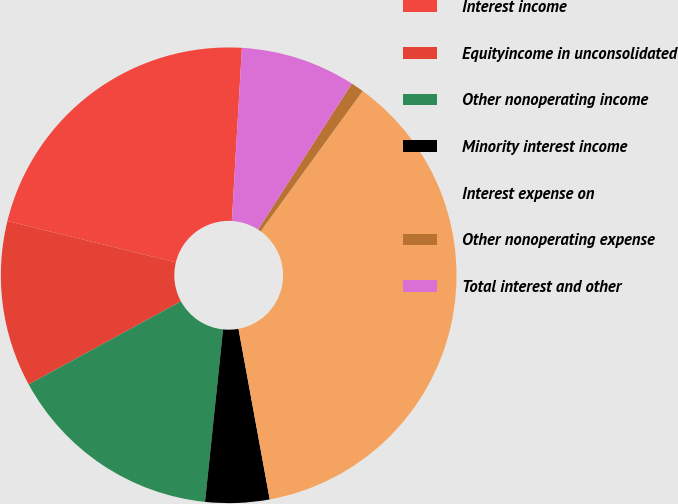Convert chart. <chart><loc_0><loc_0><loc_500><loc_500><pie_chart><fcel>Interest income<fcel>Equityincome in unconsolidated<fcel>Other nonoperating income<fcel>Minority interest income<fcel>Interest expense on<fcel>Other nonoperating expense<fcel>Total interest and other<nl><fcel>22.1%<fcel>11.78%<fcel>15.4%<fcel>4.54%<fcel>37.12%<fcel>0.92%<fcel>8.16%<nl></chart> 